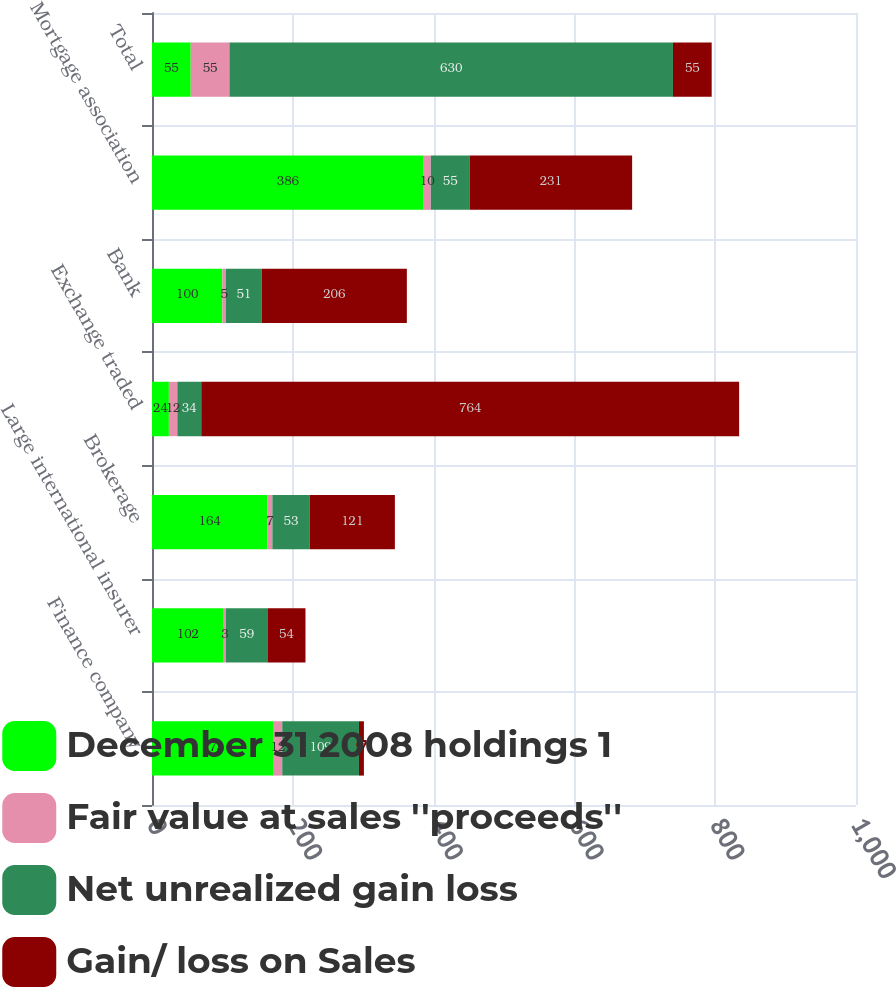<chart> <loc_0><loc_0><loc_500><loc_500><stacked_bar_chart><ecel><fcel>Finance company<fcel>Large international insurer<fcel>Brokerage<fcel>Exchange traded<fcel>Bank<fcel>Mortgage association<fcel>Total<nl><fcel>December 31 2008 holdings 1<fcel>173<fcel>102<fcel>164<fcel>24<fcel>100<fcel>386<fcel>55<nl><fcel>Fair value at sales ''proceeds''<fcel>12<fcel>3<fcel>7<fcel>12<fcel>5<fcel>10<fcel>55<nl><fcel>Net unrealized gain loss<fcel>109<fcel>59<fcel>53<fcel>34<fcel>51<fcel>55<fcel>630<nl><fcel>Gain/ loss on Sales<fcel>7<fcel>54<fcel>121<fcel>764<fcel>206<fcel>231<fcel>55<nl></chart> 